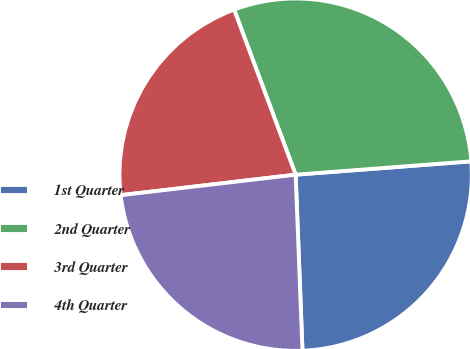<chart> <loc_0><loc_0><loc_500><loc_500><pie_chart><fcel>1st Quarter<fcel>2nd Quarter<fcel>3rd Quarter<fcel>4th Quarter<nl><fcel>25.59%<fcel>29.47%<fcel>21.18%<fcel>23.76%<nl></chart> 